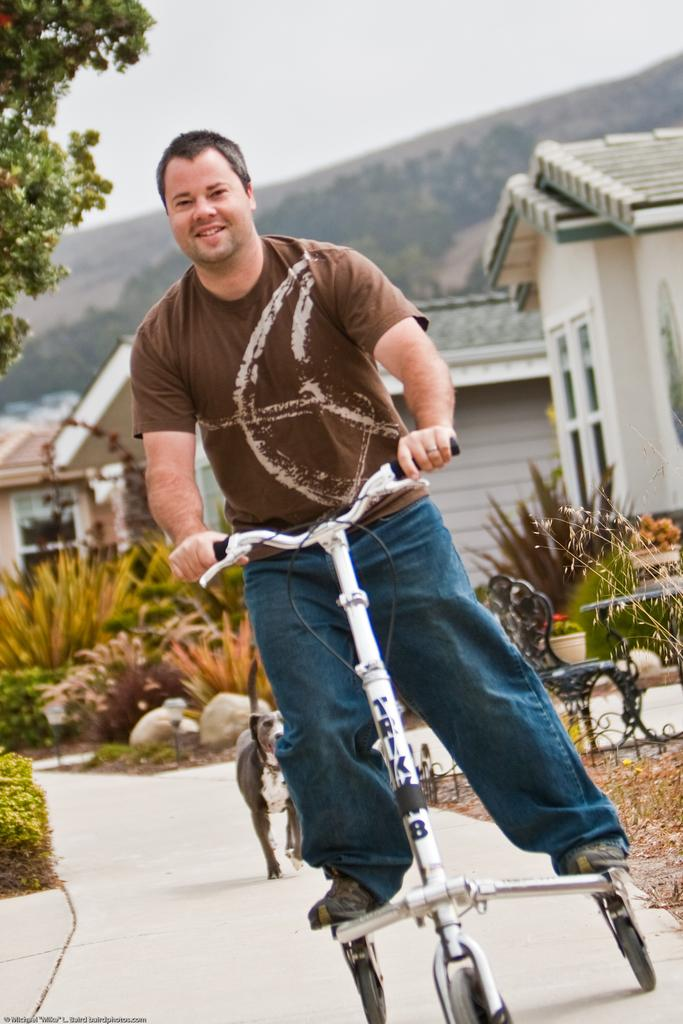What is the person in the image doing? There is a person riding a vehicle in the image. What animal is present in the image? There is a dog behind the person. What type of vegetation can be seen in the image? There are plants visible in the image. What can be seen in the distance in the image? There is a building in the background of the image. How does the person in the image express their pain while riding the vehicle? There is no indication of pain in the image; the person is simply riding the vehicle. 